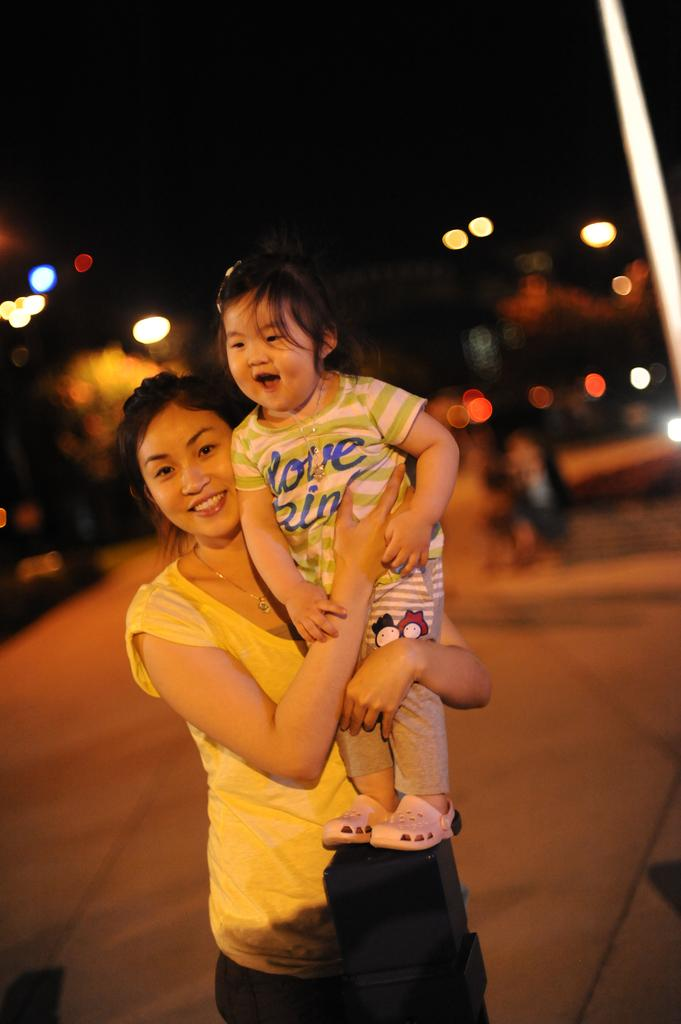Who is the main subject in the image? There is a woman in the image. What is the woman doing in the image? The woman is holding a girl. What is the woman wearing in the image? The woman is wearing a yellow t-shirt. What is the emotional state of the people in the image? The people in the image are smiling. How would you describe the background of the image? The background of the image is blurred. What type of bell can be heard ringing in the image? There is no bell present in the image, and therefore no sound can be heard. 